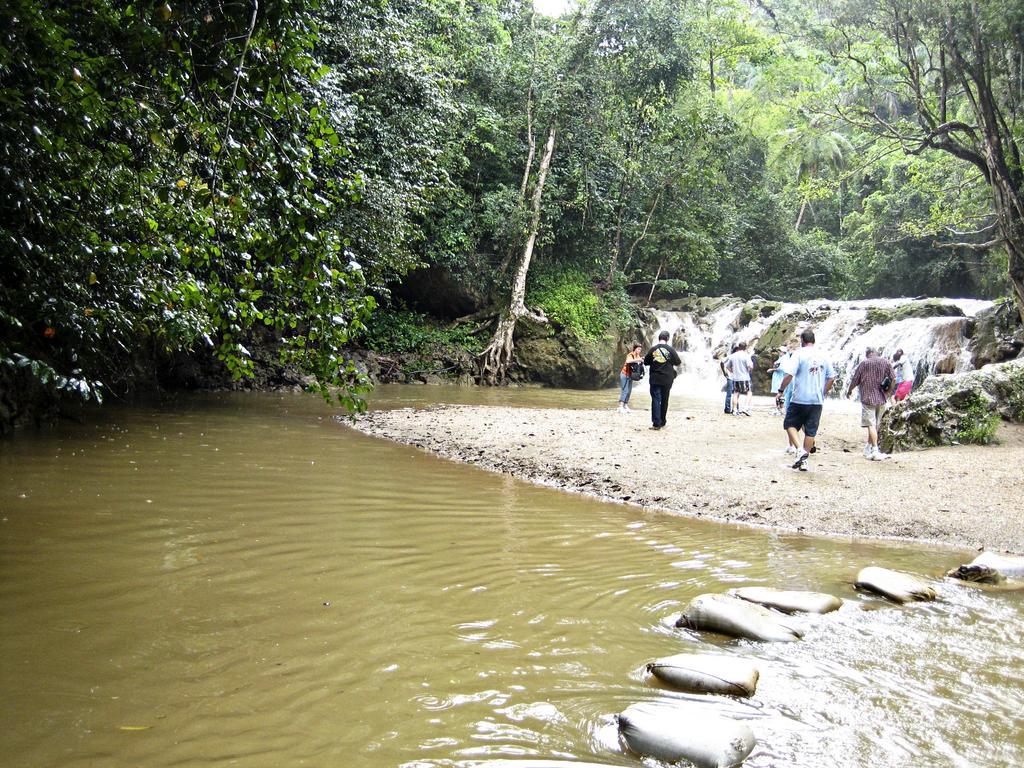How would you summarize this image in a sentence or two? This image is taken outdoors. At the bottom of the there is a lake with water and stones. In the background there are many trees and plants. In the middle of the image a few people are standing on the ground and a few are walking. There are a few rocks. 